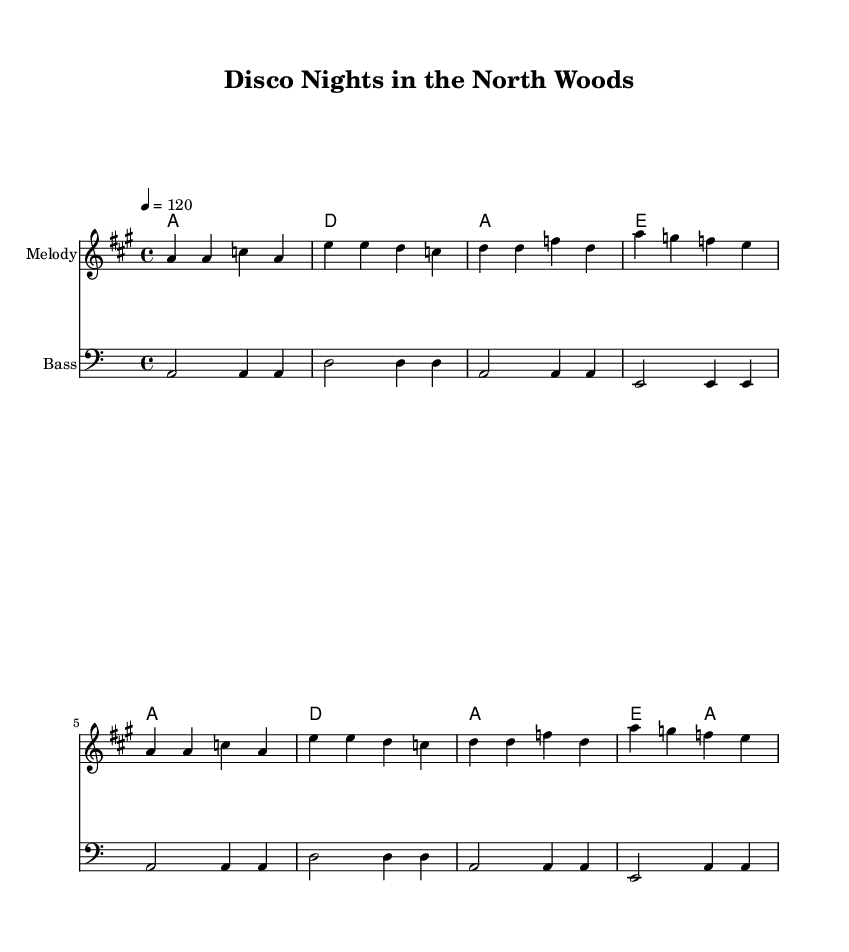What is the key signature of this music? The key signature is A major, which has three sharps (F#, C#, G#). You can identify this by looking at the key signature shown at the beginning of the staff.
Answer: A major What is the time signature of this music? The time signature is 4/4, indicated at the beginning of the staff. This means there are four beats in each measure and the quarter note gets one beat.
Answer: 4/4 What is the tempo marking indicated in the sheet music? The tempo is indicated as 120 beats per minute. This is shown in the tempo marking at the beginning of the music, telling the performer how fast to play.
Answer: 120 How many measures are in the melody section? The melody section contains eight measures, which are counted by the groupings of notes and rests in the melody line. Each distinct group separated by a vertical line counts as one measure.
Answer: Eight What chords are used in the harmonies? The chords used are A, D, and E. To find this, you can look at the chord names written above the staff, each representing the harmonies played alongside the melody.
Answer: A, D, E Does this piece have a bass line? Yes, the composition includes a bass line, which is indicated by the bass clef at the beginning of the staff. The bass line provides depth and rhythmic foundation to the music.
Answer: Yes What genre of music is this arrangement intended to represent? This arrangement represents disco music, which is characterized by its danceable rhythms and upbeat style. You can deduce this from the title "Disco Nights in the North Woods" and the lively rhythm.
Answer: Disco 